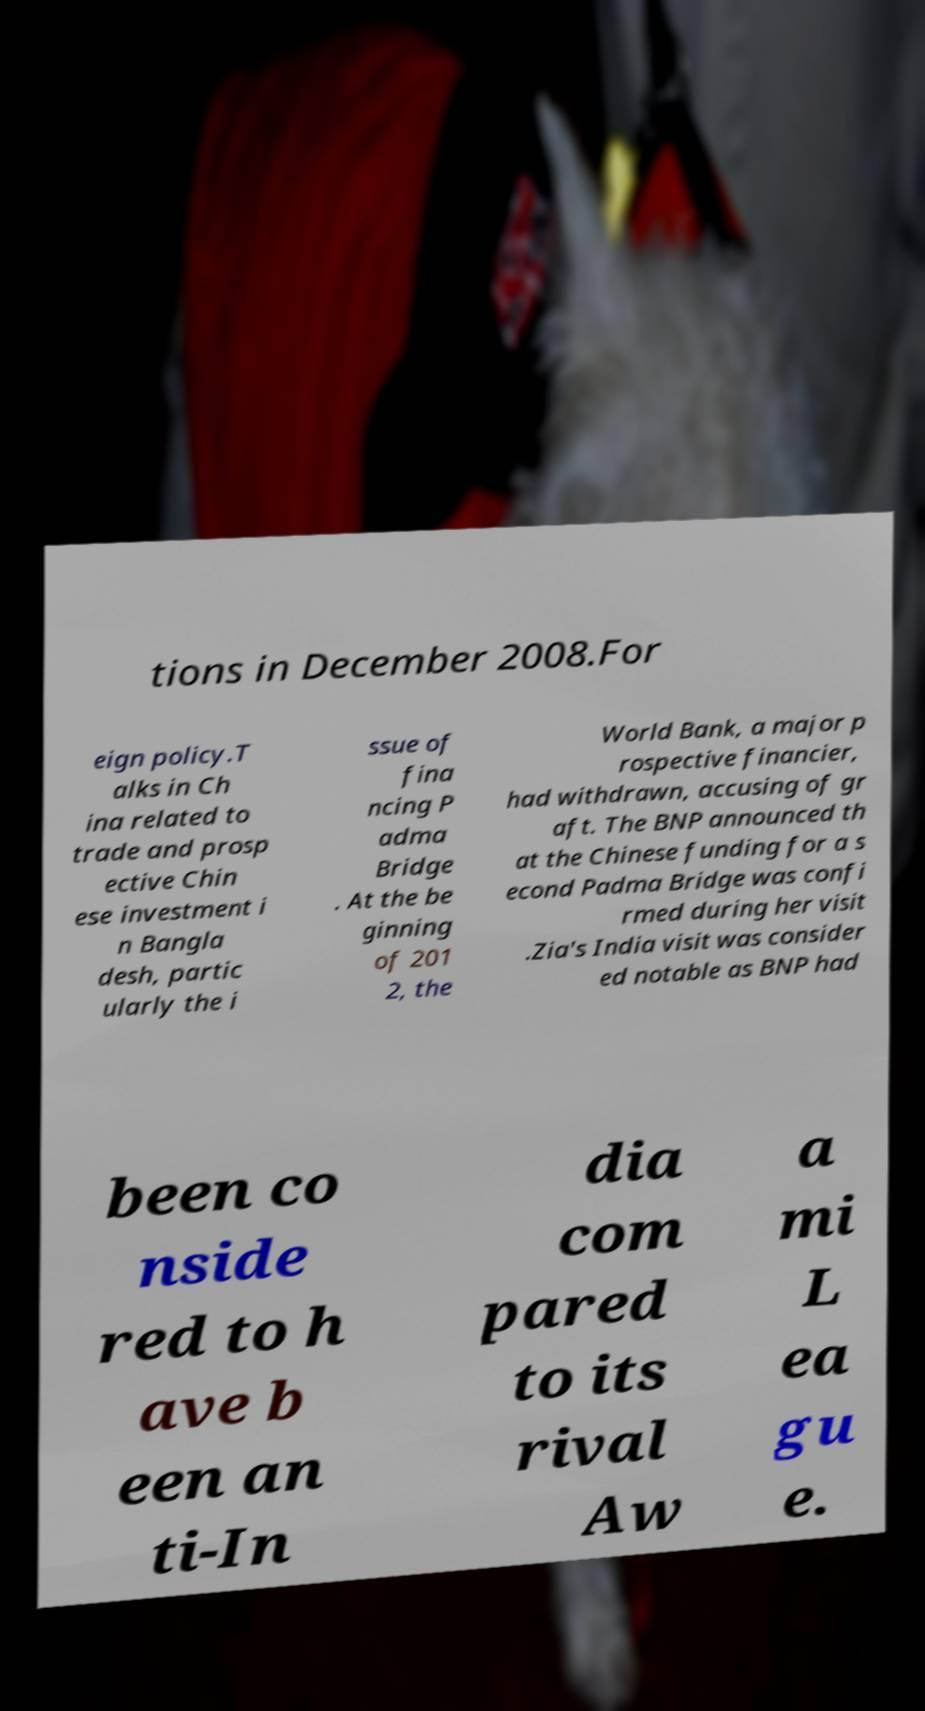Please identify and transcribe the text found in this image. tions in December 2008.For eign policy.T alks in Ch ina related to trade and prosp ective Chin ese investment i n Bangla desh, partic ularly the i ssue of fina ncing P adma Bridge . At the be ginning of 201 2, the World Bank, a major p rospective financier, had withdrawn, accusing of gr aft. The BNP announced th at the Chinese funding for a s econd Padma Bridge was confi rmed during her visit .Zia's India visit was consider ed notable as BNP had been co nside red to h ave b een an ti-In dia com pared to its rival Aw a mi L ea gu e. 